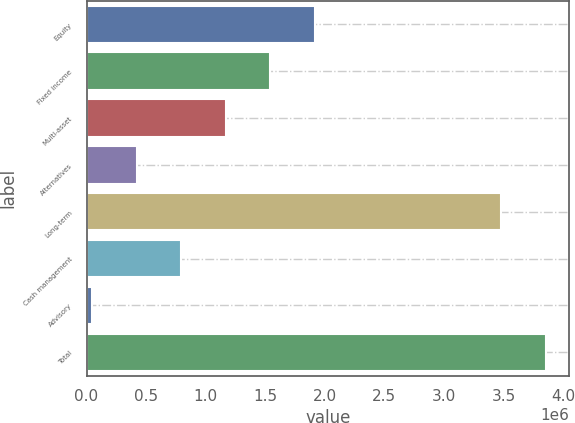<chart> <loc_0><loc_0><loc_500><loc_500><bar_chart><fcel>Equity<fcel>Fixed income<fcel>Multi-asset<fcel>Alternatives<fcel>Long-term<fcel>Cash management<fcel>Advisory<fcel>Total<nl><fcel>1.91853e+06<fcel>1.54392e+06<fcel>1.16931e+06<fcel>420090<fcel>3.48237e+06<fcel>794701<fcel>45479<fcel>3.85698e+06<nl></chart> 